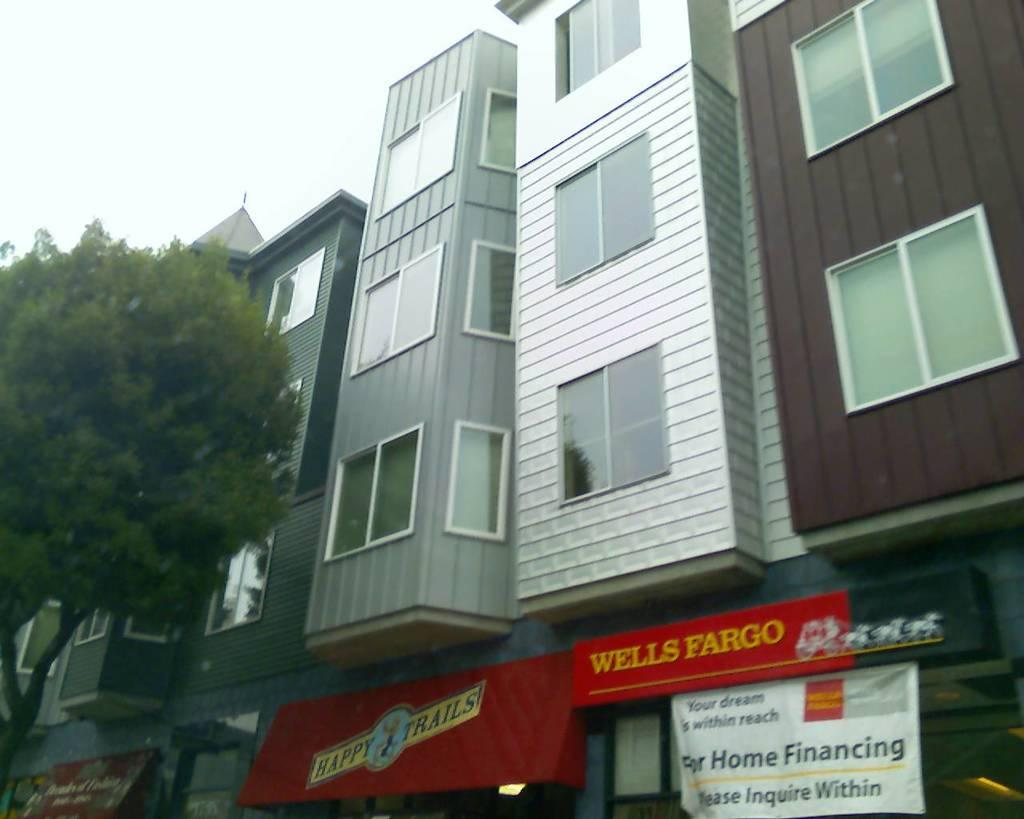What type of structure is in the image? There is a building in the image. What colors are used on the building? The building has brown and gray colors. What type of windows are on the building? There are glass windows on the building. What is attached to the wall of the building? There is a red color board attached to the wall. What type of vegetation is in the image? There are trees with green color in the image. What is visible in the sky in the image? The sky is visible in white color. How does the heart rate of the trees in the image compare to the level of the sky? There are no hearts or heart rates mentioned in the image, and the sky's level is not relevant to the trees' appearance. 